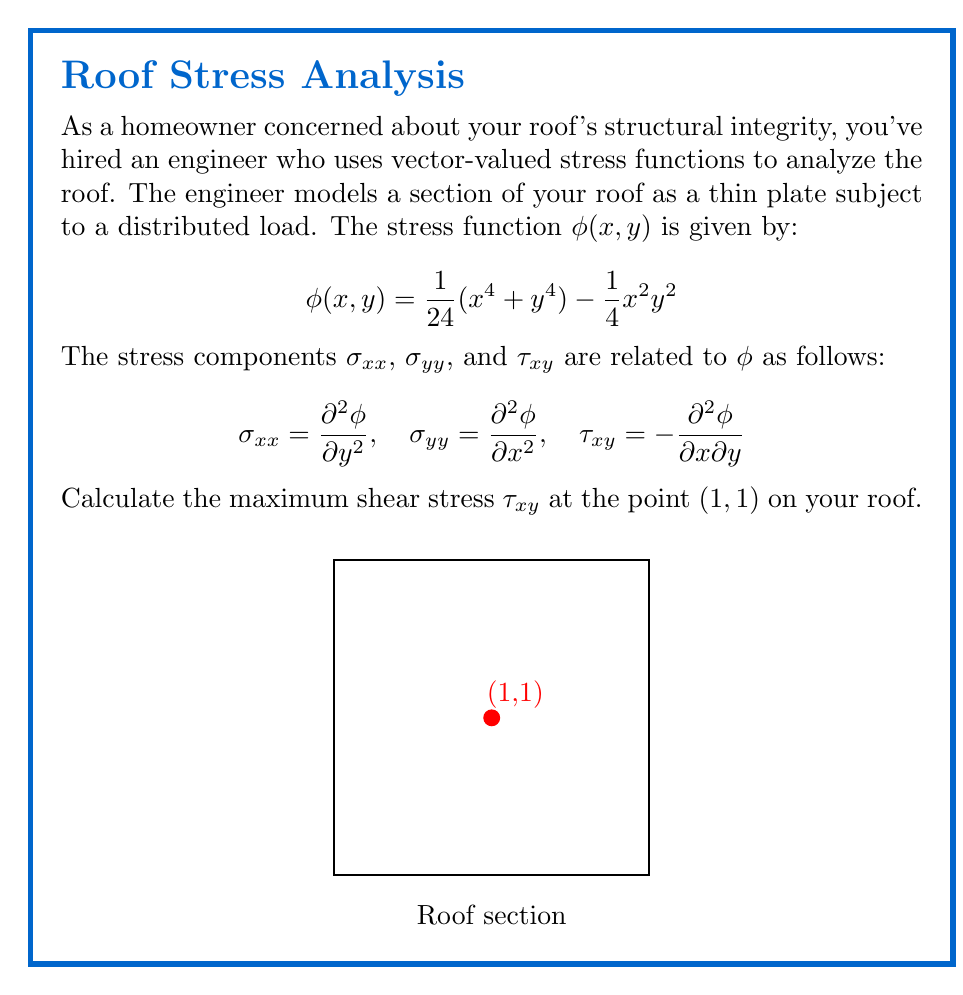Solve this math problem. To find the maximum shear stress $\tau_{xy}$ at the point (1,1), we need to follow these steps:

1) First, recall the formula for $\tau_{xy}$:
   $$\tau_{xy} = -\frac{\partial^2\phi}{\partial x\partial y}$$

2) We need to calculate $\frac{\partial^2\phi}{\partial x\partial y}$. Let's do this step by step:

   a) First, calculate $\frac{\partial\phi}{\partial x}$:
      $$\frac{\partial\phi}{\partial x} = \frac{1}{6}x^3 - \frac{1}{2}xy^2$$

   b) Now, calculate $\frac{\partial^2\phi}{\partial x\partial y}$:
      $$\frac{\partial^2\phi}{\partial x\partial y} = -xy$$

3) Therefore, $\tau_{xy} = xy$

4) At the point (1,1):
   $$\tau_{xy}(1,1) = (1)(1) = 1$$

5) The negative sign in the original formula for $\tau_{xy}$ has been accounted for in step 3, so the final result is positive.

Thus, the maximum shear stress $\tau_{xy}$ at the point (1,1) on your roof is 1 (assuming the units are consistent with the stress function, typically pascals or psi).
Answer: 1 (in consistent units) 